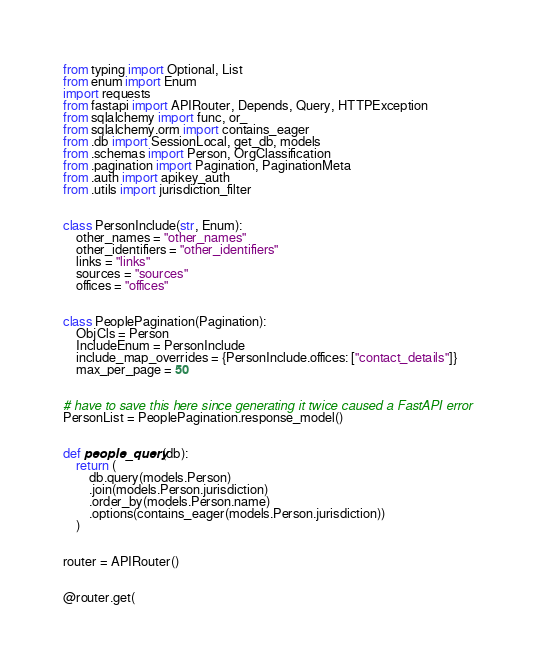<code> <loc_0><loc_0><loc_500><loc_500><_Python_>from typing import Optional, List
from enum import Enum
import requests
from fastapi import APIRouter, Depends, Query, HTTPException
from sqlalchemy import func, or_
from sqlalchemy.orm import contains_eager
from .db import SessionLocal, get_db, models
from .schemas import Person, OrgClassification
from .pagination import Pagination, PaginationMeta
from .auth import apikey_auth
from .utils import jurisdiction_filter


class PersonInclude(str, Enum):
    other_names = "other_names"
    other_identifiers = "other_identifiers"
    links = "links"
    sources = "sources"
    offices = "offices"


class PeoplePagination(Pagination):
    ObjCls = Person
    IncludeEnum = PersonInclude
    include_map_overrides = {PersonInclude.offices: ["contact_details"]}
    max_per_page = 50


# have to save this here since generating it twice caused a FastAPI error
PersonList = PeoplePagination.response_model()


def people_query(db):
    return (
        db.query(models.Person)
        .join(models.Person.jurisdiction)
        .order_by(models.Person.name)
        .options(contains_eager(models.Person.jurisdiction))
    )


router = APIRouter()


@router.get(</code> 